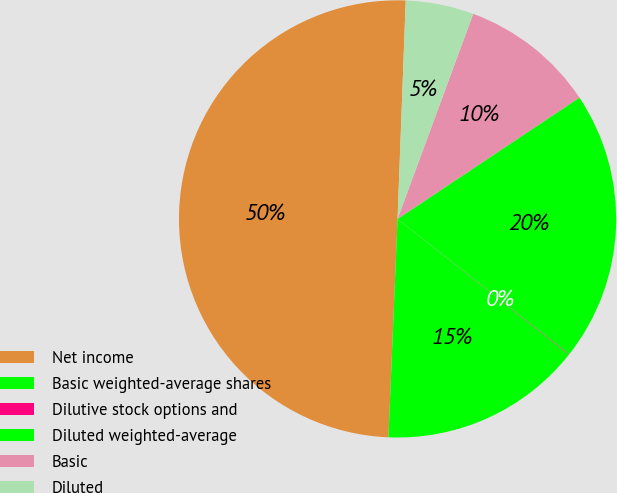Convert chart. <chart><loc_0><loc_0><loc_500><loc_500><pie_chart><fcel>Net income<fcel>Basic weighted-average shares<fcel>Dilutive stock options and<fcel>Diluted weighted-average<fcel>Basic<fcel>Diluted<nl><fcel>49.93%<fcel>15.0%<fcel>0.04%<fcel>19.99%<fcel>10.01%<fcel>5.03%<nl></chart> 